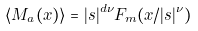<formula> <loc_0><loc_0><loc_500><loc_500>\langle M _ { a } ( x ) \rangle = | s | ^ { d \nu } F _ { m } ( x / | s | ^ { \nu } )</formula> 